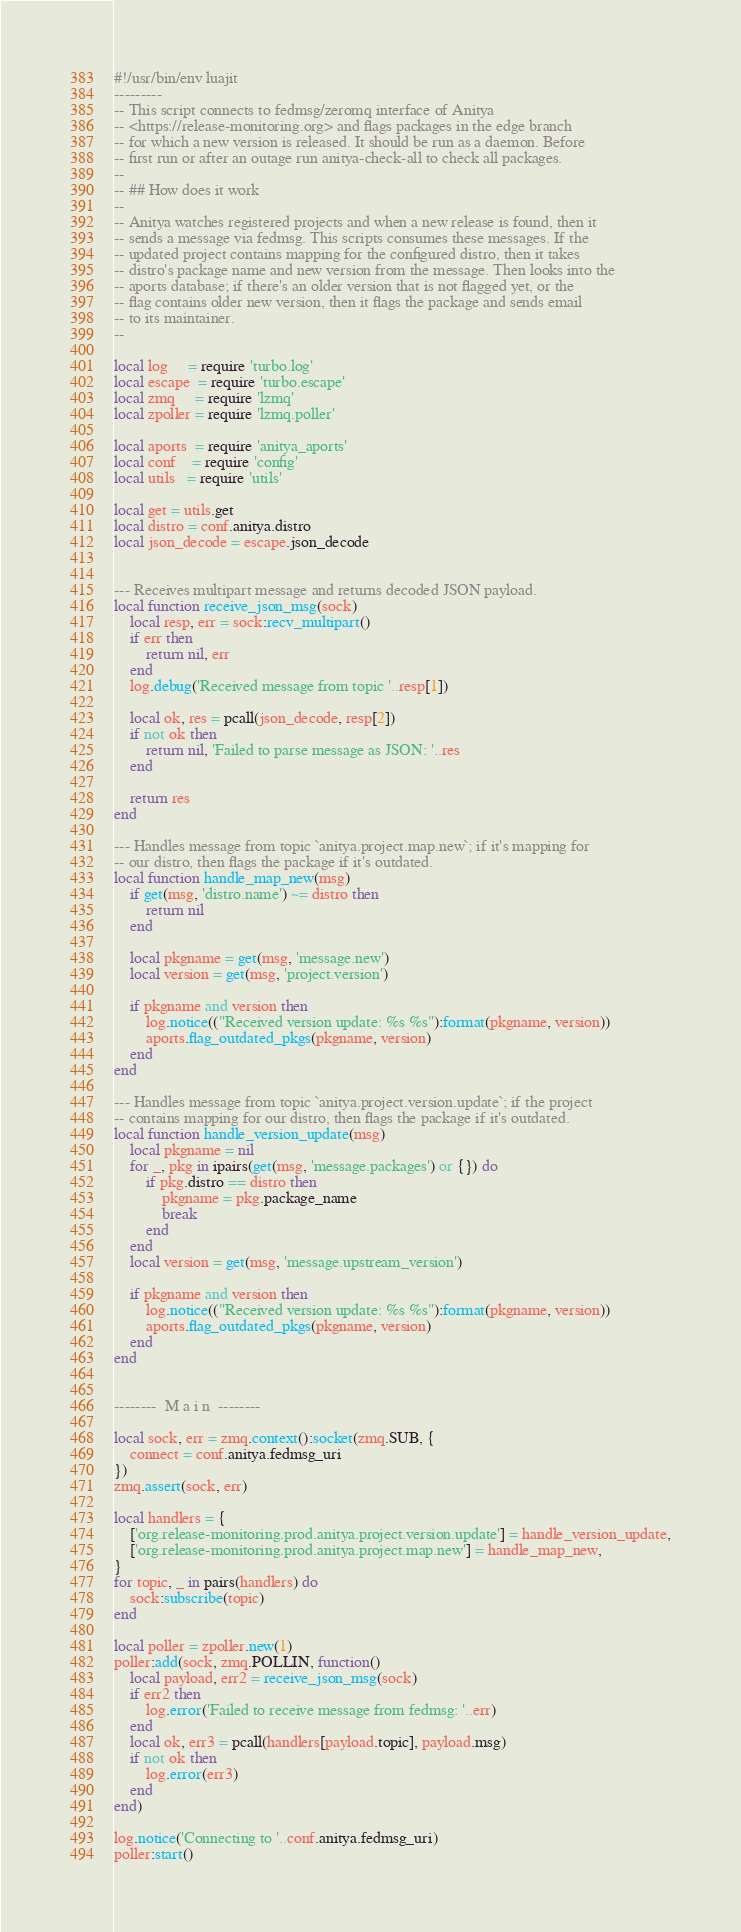Convert code to text. <code><loc_0><loc_0><loc_500><loc_500><_Lua_>#!/usr/bin/env luajit
---------
-- This script connects to fedmsg/zeromq interface of Anitya
-- <https://release-monitoring.org> and flags packages in the edge branch
-- for which a new version is released. It should be run as a daemon. Before
-- first run or after an outage run anitya-check-all to check all packages.
--
-- ## How does it work
--
-- Anitya watches registered projects and when a new release is found, then it
-- sends a message via fedmsg. This scripts consumes these messages. If the
-- updated project contains mapping for the configured distro, then it takes
-- distro's package name and new version from the message. Then looks into the
-- aports database; if there's an older version that is not flagged yet, or the
-- flag contains older new version, then it flags the package and sends email
-- to its maintainer.
--

local log     = require 'turbo.log'
local escape  = require 'turbo.escape'
local zmq     = require 'lzmq'
local zpoller = require 'lzmq.poller'

local aports  = require 'anitya_aports'
local conf    = require 'config'
local utils   = require 'utils'

local get = utils.get
local distro = conf.anitya.distro
local json_decode = escape.json_decode


--- Receives multipart message and returns decoded JSON payload.
local function receive_json_msg(sock)
    local resp, err = sock:recv_multipart()
    if err then
        return nil, err
    end
    log.debug('Received message from topic '..resp[1])

    local ok, res = pcall(json_decode, resp[2])
    if not ok then
        return nil, 'Failed to parse message as JSON: '..res
    end

    return res
end

--- Handles message from topic `anitya.project.map.new`; if it's mapping for
-- our distro, then flags the package if it's outdated.
local function handle_map_new(msg)
    if get(msg, 'distro.name') ~= distro then
        return nil
    end

    local pkgname = get(msg, 'message.new')
    local version = get(msg, 'project.version')

    if pkgname and version then
        log.notice(("Received version update: %s %s"):format(pkgname, version))
        aports.flag_outdated_pkgs(pkgname, version)
    end
end

--- Handles message from topic `anitya.project.version.update`; if the project
-- contains mapping for our distro, then flags the package if it's outdated.
local function handle_version_update(msg)
    local pkgname = nil
    for _, pkg in ipairs(get(msg, 'message.packages') or {}) do
        if pkg.distro == distro then
            pkgname = pkg.package_name
            break
        end
    end
    local version = get(msg, 'message.upstream_version')

    if pkgname and version then
        log.notice(("Received version update: %s %s"):format(pkgname, version))
        aports.flag_outdated_pkgs(pkgname, version)
    end
end


--------  M a i n  --------

local sock, err = zmq.context():socket(zmq.SUB, {
    connect = conf.anitya.fedmsg_uri
})
zmq.assert(sock, err)

local handlers = {
    ['org.release-monitoring.prod.anitya.project.version.update'] = handle_version_update,
    ['org.release-monitoring.prod.anitya.project.map.new'] = handle_map_new,
}
for topic, _ in pairs(handlers) do
    sock:subscribe(topic)
end

local poller = zpoller.new(1)
poller:add(sock, zmq.POLLIN, function()
    local payload, err2 = receive_json_msg(sock)
    if err2 then
        log.error('Failed to receive message from fedmsg: '..err)
    end
    local ok, err3 = pcall(handlers[payload.topic], payload.msg)
    if not ok then
        log.error(err3)
    end
end)

log.notice('Connecting to '..conf.anitya.fedmsg_uri)
poller:start()
</code> 